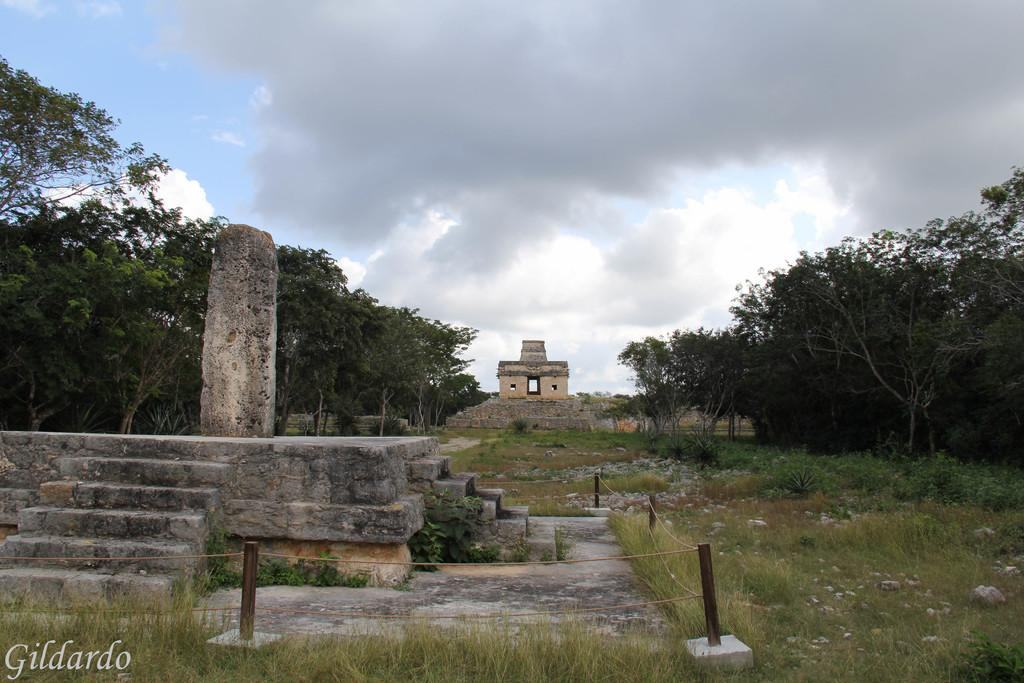Where was the image taken? The image was clicked outside. What can be seen in the middle of the image? There are trees and stairs in the middle of the image. What type of vegetation is at the bottom of the image? There is grass at the bottom of the image. What is visible at the top of the image? The sky is visible at the top of the image. How many cattle can be seen grazing on the grass in the image? There are no cattle present in the image; it features trees, stairs, grass, and the sky. What type of club is visible in the image? There is no club present in the image. 